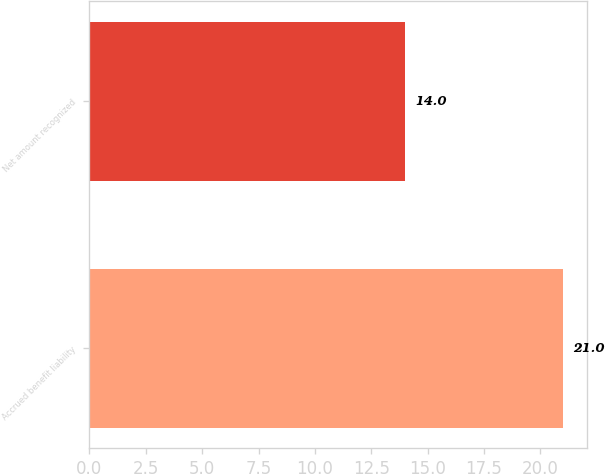Convert chart to OTSL. <chart><loc_0><loc_0><loc_500><loc_500><bar_chart><fcel>Accrued benefit liability<fcel>Net amount recognized<nl><fcel>21<fcel>14<nl></chart> 